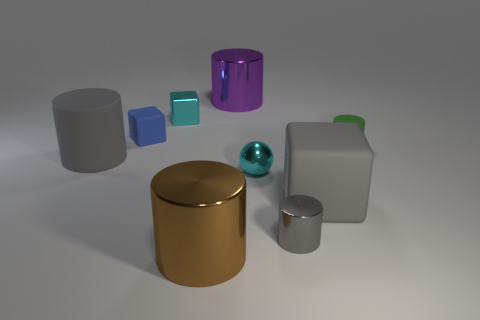Is there a cube of the same color as the metal ball?
Offer a very short reply. Yes. What number of matte things are either cubes or big cyan objects?
Make the answer very short. 2. Is there another large object made of the same material as the big brown object?
Offer a terse response. Yes. How many objects are both left of the small cyan metallic ball and behind the large brown cylinder?
Keep it short and to the point. 4. Are there fewer large brown cylinders on the right side of the small matte cylinder than small cyan balls to the left of the cyan metal block?
Offer a terse response. No. Is the large brown metallic thing the same shape as the small blue thing?
Keep it short and to the point. No. What number of other objects are there of the same size as the gray matte cube?
Make the answer very short. 3. How many things are either tiny cyan things that are in front of the small green matte object or small rubber objects on the left side of the small gray cylinder?
Provide a succinct answer. 2. How many other small gray things are the same shape as the small gray shiny object?
Offer a terse response. 0. What is the material of the cylinder that is both to the left of the big purple cylinder and in front of the large gray rubber block?
Give a very brief answer. Metal. 